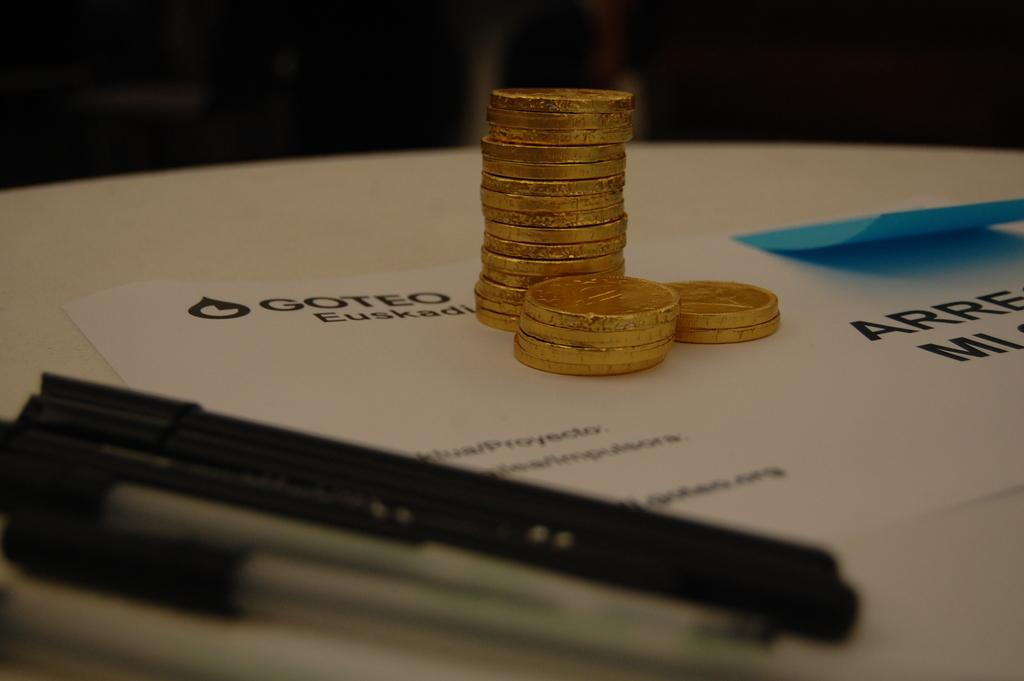<image>
Share a concise interpretation of the image provided. a stack of gold coins on a table that says 'goteo' 